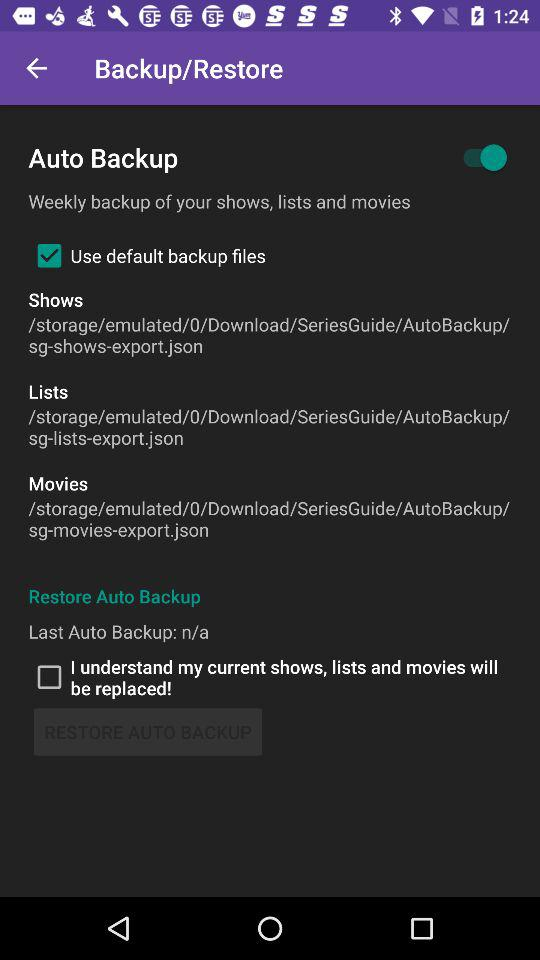What is the status of "Use default backup files"? The status is "on". 